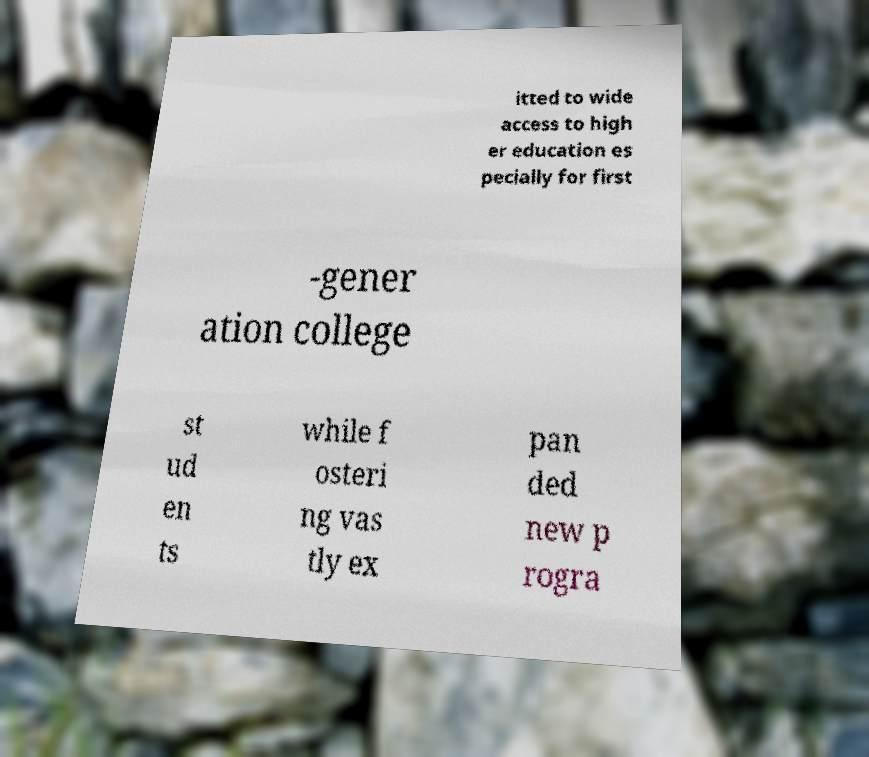I need the written content from this picture converted into text. Can you do that? itted to wide access to high er education es pecially for first -gener ation college st ud en ts while f osteri ng vas tly ex pan ded new p rogra 